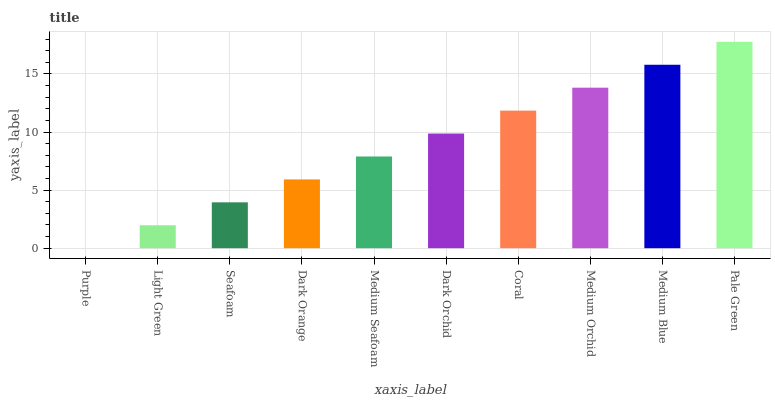Is Purple the minimum?
Answer yes or no. Yes. Is Pale Green the maximum?
Answer yes or no. Yes. Is Light Green the minimum?
Answer yes or no. No. Is Light Green the maximum?
Answer yes or no. No. Is Light Green greater than Purple?
Answer yes or no. Yes. Is Purple less than Light Green?
Answer yes or no. Yes. Is Purple greater than Light Green?
Answer yes or no. No. Is Light Green less than Purple?
Answer yes or no. No. Is Dark Orchid the high median?
Answer yes or no. Yes. Is Medium Seafoam the low median?
Answer yes or no. Yes. Is Purple the high median?
Answer yes or no. No. Is Seafoam the low median?
Answer yes or no. No. 